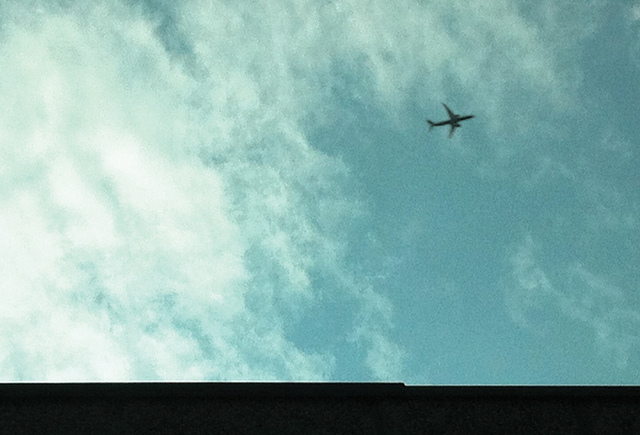<image>Which company operates this plane? I don't know which company operates the plane. It could be operated by various companies like 'boeing', 'delta', 'qantas', 'southwest', 'united', 'air canada', or 'twa'. Which company operates this plane? It is unknown which company operates this plane. There are multiple possibilities such as Boeing, Delta, Qantas, Southwest, United, Air Canada, and TWA. 